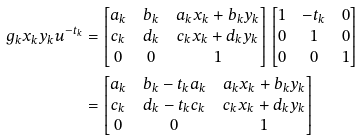<formula> <loc_0><loc_0><loc_500><loc_500>g _ { k } x _ { k } y _ { k } u ^ { - t _ { k } } & = \begin{bmatrix} a _ { k } & b _ { k } & a _ { k } x _ { k } + b _ { k } y _ { k } \\ c _ { k } & d _ { k } & c _ { k } x _ { k } + d _ { k } y _ { k } \\ 0 & 0 & 1 \end{bmatrix} \begin{bmatrix} 1 & - t _ { k } & 0 \\ 0 & 1 & 0 \\ 0 & 0 & 1 \end{bmatrix} \\ & = \begin{bmatrix} a _ { k } & b _ { k } - t _ { k } a _ { k } & a _ { k } x _ { k } + b _ { k } y _ { k } \\ c _ { k } & d _ { k } - t _ { k } c _ { k } & c _ { k } x _ { k } + d _ { k } y _ { k } \\ 0 & 0 & 1 \end{bmatrix}</formula> 